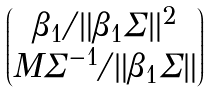Convert formula to latex. <formula><loc_0><loc_0><loc_500><loc_500>\begin{pmatrix} \beta _ { 1 } / \| \beta _ { 1 } \Sigma \| ^ { 2 } \\ M \Sigma ^ { - 1 } / \| \beta _ { 1 } \Sigma \| \end{pmatrix}</formula> 